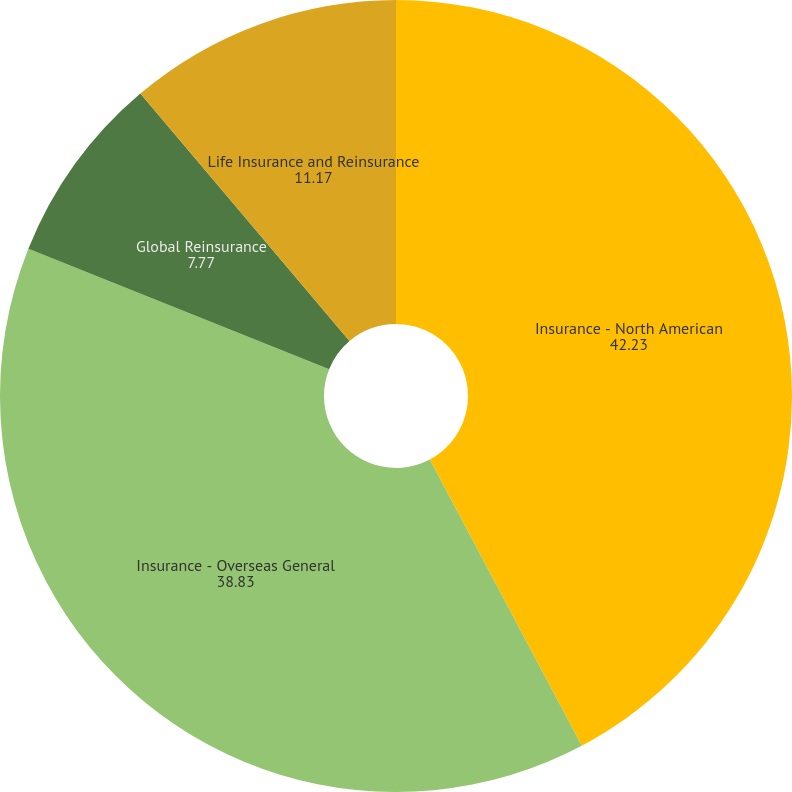<chart> <loc_0><loc_0><loc_500><loc_500><pie_chart><fcel>Insurance - North American<fcel>Insurance - Overseas General<fcel>Global Reinsurance<fcel>Life Insurance and Reinsurance<nl><fcel>42.23%<fcel>38.83%<fcel>7.77%<fcel>11.17%<nl></chart> 